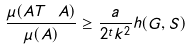Convert formula to latex. <formula><loc_0><loc_0><loc_500><loc_500>\frac { \mu ( A T \ A ) } { \mu ( A ) } \geq \frac { a } { 2 ^ { t } k ^ { 2 } } h ( G , S )</formula> 